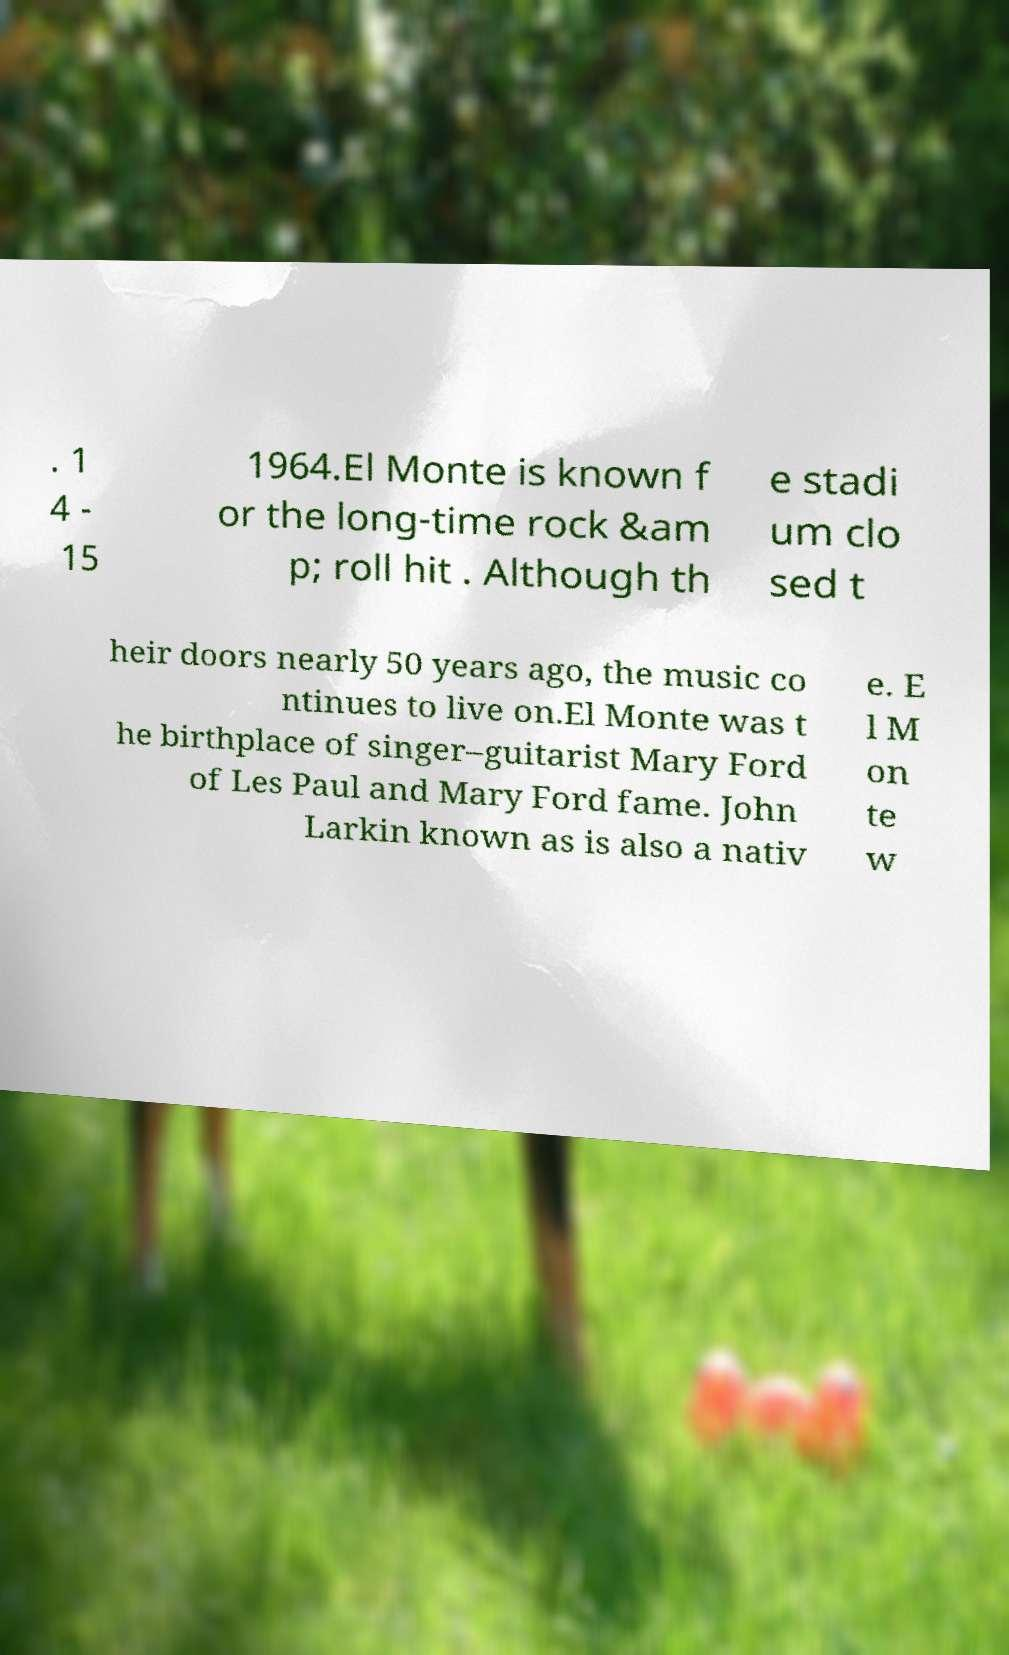I need the written content from this picture converted into text. Can you do that? . 1 4 - 15 1964.El Monte is known f or the long-time rock &am p; roll hit . Although th e stadi um clo sed t heir doors nearly 50 years ago, the music co ntinues to live on.El Monte was t he birthplace of singer–guitarist Mary Ford of Les Paul and Mary Ford fame. John Larkin known as is also a nativ e. E l M on te w 